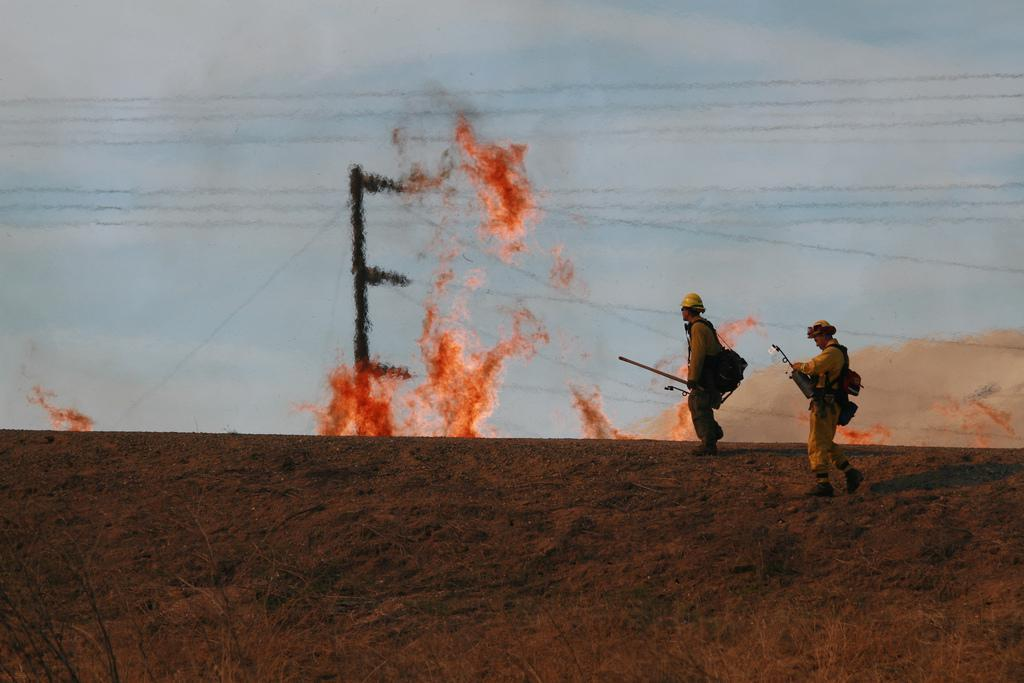What can be seen in the front of the image? There are people and plants in the front of the image. What are the people holding in the image? The people are holding objects. What is present in the background of the image? There is a pole, fire, and the sky visible in the background of the image. How many family members can be seen in the image? There is no information about family members in the image. 